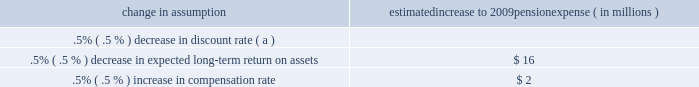The following were issued in 2007 : 2022 sfas 141 ( r ) , 201cbusiness combinations 201d 2022 sfas 160 , 201caccounting and reporting of noncontrolling interests in consolidated financial statements , an amendment of arb no .
51 201d 2022 sec staff accounting bulletin no .
109 2022 fin 46 ( r ) 7 , 201capplication of fasb interpretation no .
46 ( r ) to investment companies 201d 2022 fsp fin 48-1 , 201cdefinition of settlement in fasb interpretation ( 201cfin 201d ) no .
48 201d 2022 sfas 159 the following were issued in 2006 with an effective date in 2022 sfas 157 2022 the emerging issues task force ( 201ceitf 201d ) of the fasb issued eitf issue 06-4 , 201caccounting for deferred compensation and postretirement benefit aspects of endorsement split-dollar life insurance arrangements 201d status of defined benefit pension plan we have a noncontributory , qualified defined benefit pension plan ( 201cplan 201d or 201cpension plan 201d ) covering eligible employees .
Benefits are derived from a cash balance formula based on compensation levels , age and length of service .
Pension contributions are based on an actuarially determined amount necessary to fund total benefits payable to plan participants .
Consistent with our investment strategy , plan assets are primarily invested in equity investments and fixed income instruments .
Plan fiduciaries determine and review the plan 2019s investment policy .
We calculate the expense associated with the pension plan in accordance with sfas 87 , 201cemployers 2019 accounting for pensions , 201d and we use assumptions and methods that are compatible with the requirements of sfas 87 , including a policy of reflecting trust assets at their fair market value .
On an annual basis , we review the actuarial assumptions related to the pension plan , including the discount rate , the rate of compensation increase and the expected return on plan assets .
The discount rate and compensation increase assumptions do not significantly affect pension expense .
However , the expected long-term return on assets assumption does significantly affect pension expense .
The expected long-term return on plan assets for determining net periodic pension cost for 2008 was 8.25% ( 8.25 % ) , unchanged from 2007 .
Under current accounting rules , the difference between expected long-term returns and actual returns is accumulated and amortized to pension expense over future periods .
Each one percentage point difference in actual return compared with our expected return causes expense in subsequent years to change by up to $ 7 million as the impact is amortized into results of operations .
The table below reflects the estimated effects on pension expense of certain changes in annual assumptions , using 2009 estimated expense as a baseline .
Change in assumption estimated increase to 2009 pension expense ( in millions ) .
( a ) de minimis .
We currently estimate a pretax pension expense of $ 124 million in 2009 compared with a pretax benefit of $ 32 million in 2008 .
The 2009 values and sensitivities shown above include the qualified defined benefit plan maintained by national city that we merged into the pnc plan as of december 31 , 2008 .
The expected increase in pension cost is attributable not only to the national city acquisition , but also to the significant variance between 2008 actual investment returns and long-term expected returns .
Our pension plan contribution requirements are not particularly sensitive to actuarial assumptions .
Investment performance has the most impact on contribution requirements and will drive the amount of permitted contributions in future years .
Also , current law , including the provisions of the pension protection act of 2006 , sets limits as to both minimum and maximum contributions to the plan .
We expect that the minimum required contributions under the law will be zero for 2009 .
We maintain other defined benefit plans that have a less significant effect on financial results , including various nonqualified supplemental retirement plans for certain employees .
See note 15 employee benefit plans in the notes to consolidated financial statements in item 8 of this report for additional information .
Risk management we encounter risk as part of the normal course of our business and we design risk management processes to help manage these risks .
This risk management section first provides an overview of the risk measurement , control strategies , and monitoring aspects of our corporate-level risk management processes .
Following that discussion is an analysis of the risk management process for what we view as our primary areas of risk : credit , operational , liquidity , and market .
The discussion of market risk is further subdivided into interest rate , trading , and equity and other investment risk areas .
Our use of financial derivatives as part of our overall asset and liability risk management process is also addressed within the risk management section of this item 7 .
In appropriate places within this section , historical performance is also addressed. .
What was the change in the expected long-term return on plan assets for determining net periodic pension cost in 2008 compared to 2007? 
Computations: (8.25 - 8.25)
Answer: 0.0. 